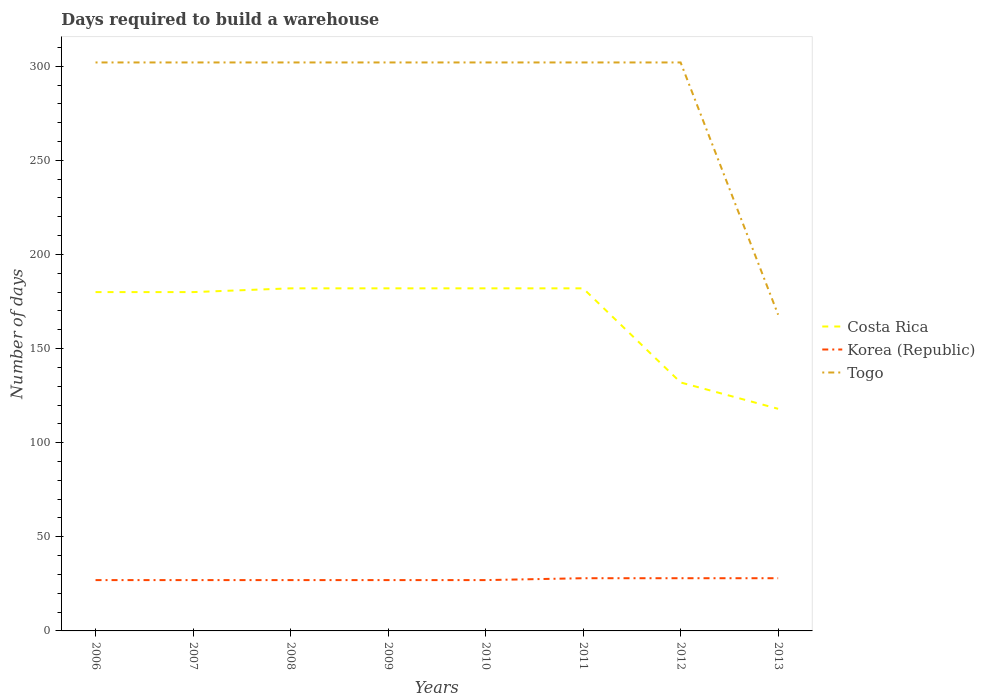How many different coloured lines are there?
Your answer should be very brief. 3. Is the number of lines equal to the number of legend labels?
Make the answer very short. Yes. Across all years, what is the maximum days required to build a warehouse in in Costa Rica?
Your answer should be compact. 118. What is the difference between the highest and the second highest days required to build a warehouse in in Korea (Republic)?
Your answer should be compact. 1. What is the difference between the highest and the lowest days required to build a warehouse in in Korea (Republic)?
Give a very brief answer. 3. How many lines are there?
Your response must be concise. 3. What is the difference between two consecutive major ticks on the Y-axis?
Ensure brevity in your answer.  50. Where does the legend appear in the graph?
Offer a terse response. Center right. How many legend labels are there?
Offer a very short reply. 3. How are the legend labels stacked?
Keep it short and to the point. Vertical. What is the title of the graph?
Provide a short and direct response. Days required to build a warehouse. What is the label or title of the X-axis?
Your response must be concise. Years. What is the label or title of the Y-axis?
Make the answer very short. Number of days. What is the Number of days in Costa Rica in 2006?
Provide a succinct answer. 180. What is the Number of days in Togo in 2006?
Provide a succinct answer. 302. What is the Number of days in Costa Rica in 2007?
Provide a succinct answer. 180. What is the Number of days of Korea (Republic) in 2007?
Your answer should be very brief. 27. What is the Number of days of Togo in 2007?
Your answer should be very brief. 302. What is the Number of days in Costa Rica in 2008?
Your response must be concise. 182. What is the Number of days of Korea (Republic) in 2008?
Provide a succinct answer. 27. What is the Number of days of Togo in 2008?
Give a very brief answer. 302. What is the Number of days of Costa Rica in 2009?
Give a very brief answer. 182. What is the Number of days in Togo in 2009?
Your answer should be compact. 302. What is the Number of days of Costa Rica in 2010?
Your response must be concise. 182. What is the Number of days in Togo in 2010?
Your response must be concise. 302. What is the Number of days of Costa Rica in 2011?
Provide a succinct answer. 182. What is the Number of days of Korea (Republic) in 2011?
Offer a terse response. 28. What is the Number of days in Togo in 2011?
Your answer should be very brief. 302. What is the Number of days in Costa Rica in 2012?
Your answer should be compact. 132. What is the Number of days in Togo in 2012?
Provide a short and direct response. 302. What is the Number of days in Costa Rica in 2013?
Your response must be concise. 118. What is the Number of days in Togo in 2013?
Make the answer very short. 168. Across all years, what is the maximum Number of days of Costa Rica?
Ensure brevity in your answer.  182. Across all years, what is the maximum Number of days of Togo?
Offer a very short reply. 302. Across all years, what is the minimum Number of days of Costa Rica?
Give a very brief answer. 118. Across all years, what is the minimum Number of days in Korea (Republic)?
Give a very brief answer. 27. Across all years, what is the minimum Number of days of Togo?
Your answer should be compact. 168. What is the total Number of days in Costa Rica in the graph?
Provide a succinct answer. 1338. What is the total Number of days in Korea (Republic) in the graph?
Your answer should be compact. 219. What is the total Number of days of Togo in the graph?
Provide a short and direct response. 2282. What is the difference between the Number of days in Togo in 2006 and that in 2007?
Your response must be concise. 0. What is the difference between the Number of days in Costa Rica in 2006 and that in 2009?
Offer a terse response. -2. What is the difference between the Number of days of Korea (Republic) in 2006 and that in 2009?
Keep it short and to the point. 0. What is the difference between the Number of days in Costa Rica in 2006 and that in 2010?
Offer a very short reply. -2. What is the difference between the Number of days of Costa Rica in 2006 and that in 2012?
Offer a terse response. 48. What is the difference between the Number of days of Korea (Republic) in 2006 and that in 2012?
Offer a terse response. -1. What is the difference between the Number of days in Togo in 2006 and that in 2012?
Make the answer very short. 0. What is the difference between the Number of days of Togo in 2006 and that in 2013?
Offer a terse response. 134. What is the difference between the Number of days in Korea (Republic) in 2007 and that in 2008?
Offer a terse response. 0. What is the difference between the Number of days in Costa Rica in 2007 and that in 2009?
Make the answer very short. -2. What is the difference between the Number of days in Togo in 2007 and that in 2009?
Offer a terse response. 0. What is the difference between the Number of days of Costa Rica in 2007 and that in 2010?
Your answer should be compact. -2. What is the difference between the Number of days of Togo in 2007 and that in 2010?
Offer a very short reply. 0. What is the difference between the Number of days in Togo in 2007 and that in 2012?
Make the answer very short. 0. What is the difference between the Number of days of Costa Rica in 2007 and that in 2013?
Your response must be concise. 62. What is the difference between the Number of days in Korea (Republic) in 2007 and that in 2013?
Your answer should be compact. -1. What is the difference between the Number of days in Togo in 2007 and that in 2013?
Your answer should be very brief. 134. What is the difference between the Number of days of Korea (Republic) in 2008 and that in 2010?
Your response must be concise. 0. What is the difference between the Number of days of Togo in 2008 and that in 2010?
Provide a short and direct response. 0. What is the difference between the Number of days in Costa Rica in 2008 and that in 2011?
Ensure brevity in your answer.  0. What is the difference between the Number of days in Korea (Republic) in 2008 and that in 2011?
Your answer should be very brief. -1. What is the difference between the Number of days of Costa Rica in 2008 and that in 2012?
Offer a terse response. 50. What is the difference between the Number of days of Korea (Republic) in 2008 and that in 2012?
Provide a short and direct response. -1. What is the difference between the Number of days of Togo in 2008 and that in 2012?
Offer a terse response. 0. What is the difference between the Number of days in Costa Rica in 2008 and that in 2013?
Ensure brevity in your answer.  64. What is the difference between the Number of days in Korea (Republic) in 2008 and that in 2013?
Offer a terse response. -1. What is the difference between the Number of days of Togo in 2008 and that in 2013?
Provide a succinct answer. 134. What is the difference between the Number of days in Costa Rica in 2009 and that in 2011?
Offer a very short reply. 0. What is the difference between the Number of days in Costa Rica in 2009 and that in 2012?
Your answer should be very brief. 50. What is the difference between the Number of days in Togo in 2009 and that in 2012?
Keep it short and to the point. 0. What is the difference between the Number of days of Costa Rica in 2009 and that in 2013?
Offer a very short reply. 64. What is the difference between the Number of days of Togo in 2009 and that in 2013?
Your answer should be compact. 134. What is the difference between the Number of days of Korea (Republic) in 2010 and that in 2011?
Offer a very short reply. -1. What is the difference between the Number of days of Korea (Republic) in 2010 and that in 2012?
Give a very brief answer. -1. What is the difference between the Number of days of Togo in 2010 and that in 2012?
Your response must be concise. 0. What is the difference between the Number of days in Togo in 2010 and that in 2013?
Keep it short and to the point. 134. What is the difference between the Number of days of Costa Rica in 2011 and that in 2012?
Provide a short and direct response. 50. What is the difference between the Number of days of Costa Rica in 2011 and that in 2013?
Make the answer very short. 64. What is the difference between the Number of days of Togo in 2011 and that in 2013?
Offer a very short reply. 134. What is the difference between the Number of days in Costa Rica in 2012 and that in 2013?
Your answer should be compact. 14. What is the difference between the Number of days in Korea (Republic) in 2012 and that in 2013?
Make the answer very short. 0. What is the difference between the Number of days in Togo in 2012 and that in 2013?
Give a very brief answer. 134. What is the difference between the Number of days of Costa Rica in 2006 and the Number of days of Korea (Republic) in 2007?
Offer a very short reply. 153. What is the difference between the Number of days in Costa Rica in 2006 and the Number of days in Togo in 2007?
Your answer should be very brief. -122. What is the difference between the Number of days of Korea (Republic) in 2006 and the Number of days of Togo in 2007?
Make the answer very short. -275. What is the difference between the Number of days in Costa Rica in 2006 and the Number of days in Korea (Republic) in 2008?
Ensure brevity in your answer.  153. What is the difference between the Number of days in Costa Rica in 2006 and the Number of days in Togo in 2008?
Your answer should be very brief. -122. What is the difference between the Number of days of Korea (Republic) in 2006 and the Number of days of Togo in 2008?
Your answer should be very brief. -275. What is the difference between the Number of days in Costa Rica in 2006 and the Number of days in Korea (Republic) in 2009?
Provide a succinct answer. 153. What is the difference between the Number of days of Costa Rica in 2006 and the Number of days of Togo in 2009?
Provide a short and direct response. -122. What is the difference between the Number of days of Korea (Republic) in 2006 and the Number of days of Togo in 2009?
Offer a very short reply. -275. What is the difference between the Number of days of Costa Rica in 2006 and the Number of days of Korea (Republic) in 2010?
Give a very brief answer. 153. What is the difference between the Number of days of Costa Rica in 2006 and the Number of days of Togo in 2010?
Make the answer very short. -122. What is the difference between the Number of days in Korea (Republic) in 2006 and the Number of days in Togo in 2010?
Give a very brief answer. -275. What is the difference between the Number of days of Costa Rica in 2006 and the Number of days of Korea (Republic) in 2011?
Your answer should be compact. 152. What is the difference between the Number of days of Costa Rica in 2006 and the Number of days of Togo in 2011?
Keep it short and to the point. -122. What is the difference between the Number of days in Korea (Republic) in 2006 and the Number of days in Togo in 2011?
Your answer should be very brief. -275. What is the difference between the Number of days of Costa Rica in 2006 and the Number of days of Korea (Republic) in 2012?
Provide a short and direct response. 152. What is the difference between the Number of days in Costa Rica in 2006 and the Number of days in Togo in 2012?
Give a very brief answer. -122. What is the difference between the Number of days of Korea (Republic) in 2006 and the Number of days of Togo in 2012?
Offer a terse response. -275. What is the difference between the Number of days in Costa Rica in 2006 and the Number of days in Korea (Republic) in 2013?
Keep it short and to the point. 152. What is the difference between the Number of days in Costa Rica in 2006 and the Number of days in Togo in 2013?
Ensure brevity in your answer.  12. What is the difference between the Number of days in Korea (Republic) in 2006 and the Number of days in Togo in 2013?
Offer a very short reply. -141. What is the difference between the Number of days in Costa Rica in 2007 and the Number of days in Korea (Republic) in 2008?
Make the answer very short. 153. What is the difference between the Number of days in Costa Rica in 2007 and the Number of days in Togo in 2008?
Keep it short and to the point. -122. What is the difference between the Number of days of Korea (Republic) in 2007 and the Number of days of Togo in 2008?
Offer a very short reply. -275. What is the difference between the Number of days in Costa Rica in 2007 and the Number of days in Korea (Republic) in 2009?
Offer a terse response. 153. What is the difference between the Number of days in Costa Rica in 2007 and the Number of days in Togo in 2009?
Your answer should be compact. -122. What is the difference between the Number of days of Korea (Republic) in 2007 and the Number of days of Togo in 2009?
Your answer should be very brief. -275. What is the difference between the Number of days of Costa Rica in 2007 and the Number of days of Korea (Republic) in 2010?
Provide a short and direct response. 153. What is the difference between the Number of days of Costa Rica in 2007 and the Number of days of Togo in 2010?
Provide a succinct answer. -122. What is the difference between the Number of days of Korea (Republic) in 2007 and the Number of days of Togo in 2010?
Give a very brief answer. -275. What is the difference between the Number of days of Costa Rica in 2007 and the Number of days of Korea (Republic) in 2011?
Your response must be concise. 152. What is the difference between the Number of days in Costa Rica in 2007 and the Number of days in Togo in 2011?
Offer a very short reply. -122. What is the difference between the Number of days of Korea (Republic) in 2007 and the Number of days of Togo in 2011?
Provide a succinct answer. -275. What is the difference between the Number of days in Costa Rica in 2007 and the Number of days in Korea (Republic) in 2012?
Provide a short and direct response. 152. What is the difference between the Number of days of Costa Rica in 2007 and the Number of days of Togo in 2012?
Ensure brevity in your answer.  -122. What is the difference between the Number of days in Korea (Republic) in 2007 and the Number of days in Togo in 2012?
Ensure brevity in your answer.  -275. What is the difference between the Number of days of Costa Rica in 2007 and the Number of days of Korea (Republic) in 2013?
Ensure brevity in your answer.  152. What is the difference between the Number of days in Korea (Republic) in 2007 and the Number of days in Togo in 2013?
Your answer should be compact. -141. What is the difference between the Number of days of Costa Rica in 2008 and the Number of days of Korea (Republic) in 2009?
Your answer should be very brief. 155. What is the difference between the Number of days of Costa Rica in 2008 and the Number of days of Togo in 2009?
Your answer should be very brief. -120. What is the difference between the Number of days of Korea (Republic) in 2008 and the Number of days of Togo in 2009?
Offer a terse response. -275. What is the difference between the Number of days of Costa Rica in 2008 and the Number of days of Korea (Republic) in 2010?
Make the answer very short. 155. What is the difference between the Number of days of Costa Rica in 2008 and the Number of days of Togo in 2010?
Ensure brevity in your answer.  -120. What is the difference between the Number of days in Korea (Republic) in 2008 and the Number of days in Togo in 2010?
Provide a short and direct response. -275. What is the difference between the Number of days in Costa Rica in 2008 and the Number of days in Korea (Republic) in 2011?
Give a very brief answer. 154. What is the difference between the Number of days in Costa Rica in 2008 and the Number of days in Togo in 2011?
Give a very brief answer. -120. What is the difference between the Number of days of Korea (Republic) in 2008 and the Number of days of Togo in 2011?
Make the answer very short. -275. What is the difference between the Number of days of Costa Rica in 2008 and the Number of days of Korea (Republic) in 2012?
Your response must be concise. 154. What is the difference between the Number of days in Costa Rica in 2008 and the Number of days in Togo in 2012?
Provide a short and direct response. -120. What is the difference between the Number of days in Korea (Republic) in 2008 and the Number of days in Togo in 2012?
Your answer should be very brief. -275. What is the difference between the Number of days in Costa Rica in 2008 and the Number of days in Korea (Republic) in 2013?
Keep it short and to the point. 154. What is the difference between the Number of days of Korea (Republic) in 2008 and the Number of days of Togo in 2013?
Provide a short and direct response. -141. What is the difference between the Number of days in Costa Rica in 2009 and the Number of days in Korea (Republic) in 2010?
Your answer should be very brief. 155. What is the difference between the Number of days in Costa Rica in 2009 and the Number of days in Togo in 2010?
Provide a succinct answer. -120. What is the difference between the Number of days in Korea (Republic) in 2009 and the Number of days in Togo in 2010?
Keep it short and to the point. -275. What is the difference between the Number of days of Costa Rica in 2009 and the Number of days of Korea (Republic) in 2011?
Provide a succinct answer. 154. What is the difference between the Number of days in Costa Rica in 2009 and the Number of days in Togo in 2011?
Your response must be concise. -120. What is the difference between the Number of days of Korea (Republic) in 2009 and the Number of days of Togo in 2011?
Ensure brevity in your answer.  -275. What is the difference between the Number of days in Costa Rica in 2009 and the Number of days in Korea (Republic) in 2012?
Your response must be concise. 154. What is the difference between the Number of days in Costa Rica in 2009 and the Number of days in Togo in 2012?
Provide a short and direct response. -120. What is the difference between the Number of days in Korea (Republic) in 2009 and the Number of days in Togo in 2012?
Keep it short and to the point. -275. What is the difference between the Number of days in Costa Rica in 2009 and the Number of days in Korea (Republic) in 2013?
Give a very brief answer. 154. What is the difference between the Number of days of Korea (Republic) in 2009 and the Number of days of Togo in 2013?
Ensure brevity in your answer.  -141. What is the difference between the Number of days of Costa Rica in 2010 and the Number of days of Korea (Republic) in 2011?
Provide a short and direct response. 154. What is the difference between the Number of days of Costa Rica in 2010 and the Number of days of Togo in 2011?
Offer a very short reply. -120. What is the difference between the Number of days of Korea (Republic) in 2010 and the Number of days of Togo in 2011?
Give a very brief answer. -275. What is the difference between the Number of days of Costa Rica in 2010 and the Number of days of Korea (Republic) in 2012?
Keep it short and to the point. 154. What is the difference between the Number of days in Costa Rica in 2010 and the Number of days in Togo in 2012?
Offer a very short reply. -120. What is the difference between the Number of days of Korea (Republic) in 2010 and the Number of days of Togo in 2012?
Keep it short and to the point. -275. What is the difference between the Number of days in Costa Rica in 2010 and the Number of days in Korea (Republic) in 2013?
Offer a very short reply. 154. What is the difference between the Number of days in Korea (Republic) in 2010 and the Number of days in Togo in 2013?
Offer a very short reply. -141. What is the difference between the Number of days in Costa Rica in 2011 and the Number of days in Korea (Republic) in 2012?
Provide a short and direct response. 154. What is the difference between the Number of days of Costa Rica in 2011 and the Number of days of Togo in 2012?
Offer a terse response. -120. What is the difference between the Number of days in Korea (Republic) in 2011 and the Number of days in Togo in 2012?
Provide a short and direct response. -274. What is the difference between the Number of days in Costa Rica in 2011 and the Number of days in Korea (Republic) in 2013?
Give a very brief answer. 154. What is the difference between the Number of days of Costa Rica in 2011 and the Number of days of Togo in 2013?
Your answer should be very brief. 14. What is the difference between the Number of days of Korea (Republic) in 2011 and the Number of days of Togo in 2013?
Provide a succinct answer. -140. What is the difference between the Number of days in Costa Rica in 2012 and the Number of days in Korea (Republic) in 2013?
Offer a very short reply. 104. What is the difference between the Number of days in Costa Rica in 2012 and the Number of days in Togo in 2013?
Ensure brevity in your answer.  -36. What is the difference between the Number of days of Korea (Republic) in 2012 and the Number of days of Togo in 2013?
Give a very brief answer. -140. What is the average Number of days of Costa Rica per year?
Provide a short and direct response. 167.25. What is the average Number of days in Korea (Republic) per year?
Offer a very short reply. 27.38. What is the average Number of days in Togo per year?
Your response must be concise. 285.25. In the year 2006, what is the difference between the Number of days in Costa Rica and Number of days in Korea (Republic)?
Your response must be concise. 153. In the year 2006, what is the difference between the Number of days in Costa Rica and Number of days in Togo?
Provide a short and direct response. -122. In the year 2006, what is the difference between the Number of days in Korea (Republic) and Number of days in Togo?
Provide a succinct answer. -275. In the year 2007, what is the difference between the Number of days in Costa Rica and Number of days in Korea (Republic)?
Make the answer very short. 153. In the year 2007, what is the difference between the Number of days of Costa Rica and Number of days of Togo?
Give a very brief answer. -122. In the year 2007, what is the difference between the Number of days in Korea (Republic) and Number of days in Togo?
Provide a succinct answer. -275. In the year 2008, what is the difference between the Number of days in Costa Rica and Number of days in Korea (Republic)?
Make the answer very short. 155. In the year 2008, what is the difference between the Number of days of Costa Rica and Number of days of Togo?
Your response must be concise. -120. In the year 2008, what is the difference between the Number of days of Korea (Republic) and Number of days of Togo?
Your answer should be compact. -275. In the year 2009, what is the difference between the Number of days in Costa Rica and Number of days in Korea (Republic)?
Keep it short and to the point. 155. In the year 2009, what is the difference between the Number of days of Costa Rica and Number of days of Togo?
Make the answer very short. -120. In the year 2009, what is the difference between the Number of days of Korea (Republic) and Number of days of Togo?
Make the answer very short. -275. In the year 2010, what is the difference between the Number of days of Costa Rica and Number of days of Korea (Republic)?
Keep it short and to the point. 155. In the year 2010, what is the difference between the Number of days in Costa Rica and Number of days in Togo?
Offer a very short reply. -120. In the year 2010, what is the difference between the Number of days in Korea (Republic) and Number of days in Togo?
Ensure brevity in your answer.  -275. In the year 2011, what is the difference between the Number of days in Costa Rica and Number of days in Korea (Republic)?
Provide a short and direct response. 154. In the year 2011, what is the difference between the Number of days in Costa Rica and Number of days in Togo?
Keep it short and to the point. -120. In the year 2011, what is the difference between the Number of days of Korea (Republic) and Number of days of Togo?
Keep it short and to the point. -274. In the year 2012, what is the difference between the Number of days of Costa Rica and Number of days of Korea (Republic)?
Your answer should be compact. 104. In the year 2012, what is the difference between the Number of days in Costa Rica and Number of days in Togo?
Your answer should be very brief. -170. In the year 2012, what is the difference between the Number of days in Korea (Republic) and Number of days in Togo?
Provide a succinct answer. -274. In the year 2013, what is the difference between the Number of days of Costa Rica and Number of days of Korea (Republic)?
Your answer should be very brief. 90. In the year 2013, what is the difference between the Number of days in Korea (Republic) and Number of days in Togo?
Keep it short and to the point. -140. What is the ratio of the Number of days in Korea (Republic) in 2006 to that in 2007?
Offer a terse response. 1. What is the ratio of the Number of days in Costa Rica in 2006 to that in 2008?
Make the answer very short. 0.99. What is the ratio of the Number of days in Korea (Republic) in 2006 to that in 2008?
Offer a terse response. 1. What is the ratio of the Number of days in Togo in 2006 to that in 2008?
Your answer should be very brief. 1. What is the ratio of the Number of days in Togo in 2006 to that in 2009?
Offer a terse response. 1. What is the ratio of the Number of days of Korea (Republic) in 2006 to that in 2010?
Your answer should be compact. 1. What is the ratio of the Number of days of Togo in 2006 to that in 2010?
Offer a terse response. 1. What is the ratio of the Number of days in Costa Rica in 2006 to that in 2011?
Keep it short and to the point. 0.99. What is the ratio of the Number of days of Togo in 2006 to that in 2011?
Offer a terse response. 1. What is the ratio of the Number of days in Costa Rica in 2006 to that in 2012?
Give a very brief answer. 1.36. What is the ratio of the Number of days in Korea (Republic) in 2006 to that in 2012?
Offer a very short reply. 0.96. What is the ratio of the Number of days in Costa Rica in 2006 to that in 2013?
Make the answer very short. 1.53. What is the ratio of the Number of days of Togo in 2006 to that in 2013?
Keep it short and to the point. 1.8. What is the ratio of the Number of days in Costa Rica in 2007 to that in 2008?
Ensure brevity in your answer.  0.99. What is the ratio of the Number of days in Costa Rica in 2007 to that in 2009?
Make the answer very short. 0.99. What is the ratio of the Number of days of Togo in 2007 to that in 2009?
Offer a very short reply. 1. What is the ratio of the Number of days of Korea (Republic) in 2007 to that in 2010?
Ensure brevity in your answer.  1. What is the ratio of the Number of days in Costa Rica in 2007 to that in 2011?
Provide a succinct answer. 0.99. What is the ratio of the Number of days in Togo in 2007 to that in 2011?
Your answer should be compact. 1. What is the ratio of the Number of days of Costa Rica in 2007 to that in 2012?
Your response must be concise. 1.36. What is the ratio of the Number of days in Costa Rica in 2007 to that in 2013?
Your answer should be compact. 1.53. What is the ratio of the Number of days in Togo in 2007 to that in 2013?
Keep it short and to the point. 1.8. What is the ratio of the Number of days of Costa Rica in 2008 to that in 2009?
Your response must be concise. 1. What is the ratio of the Number of days of Korea (Republic) in 2008 to that in 2009?
Give a very brief answer. 1. What is the ratio of the Number of days of Costa Rica in 2008 to that in 2010?
Provide a short and direct response. 1. What is the ratio of the Number of days in Korea (Republic) in 2008 to that in 2010?
Offer a very short reply. 1. What is the ratio of the Number of days in Togo in 2008 to that in 2010?
Your response must be concise. 1. What is the ratio of the Number of days of Togo in 2008 to that in 2011?
Provide a short and direct response. 1. What is the ratio of the Number of days of Costa Rica in 2008 to that in 2012?
Offer a very short reply. 1.38. What is the ratio of the Number of days in Korea (Republic) in 2008 to that in 2012?
Your response must be concise. 0.96. What is the ratio of the Number of days of Costa Rica in 2008 to that in 2013?
Your answer should be compact. 1.54. What is the ratio of the Number of days of Korea (Republic) in 2008 to that in 2013?
Provide a short and direct response. 0.96. What is the ratio of the Number of days in Togo in 2008 to that in 2013?
Your response must be concise. 1.8. What is the ratio of the Number of days of Costa Rica in 2009 to that in 2011?
Your answer should be compact. 1. What is the ratio of the Number of days of Costa Rica in 2009 to that in 2012?
Your answer should be compact. 1.38. What is the ratio of the Number of days of Costa Rica in 2009 to that in 2013?
Keep it short and to the point. 1.54. What is the ratio of the Number of days of Togo in 2009 to that in 2013?
Make the answer very short. 1.8. What is the ratio of the Number of days of Togo in 2010 to that in 2011?
Offer a terse response. 1. What is the ratio of the Number of days in Costa Rica in 2010 to that in 2012?
Offer a very short reply. 1.38. What is the ratio of the Number of days in Korea (Republic) in 2010 to that in 2012?
Provide a succinct answer. 0.96. What is the ratio of the Number of days in Togo in 2010 to that in 2012?
Ensure brevity in your answer.  1. What is the ratio of the Number of days in Costa Rica in 2010 to that in 2013?
Your response must be concise. 1.54. What is the ratio of the Number of days of Korea (Republic) in 2010 to that in 2013?
Your response must be concise. 0.96. What is the ratio of the Number of days of Togo in 2010 to that in 2013?
Your answer should be very brief. 1.8. What is the ratio of the Number of days of Costa Rica in 2011 to that in 2012?
Your response must be concise. 1.38. What is the ratio of the Number of days of Korea (Republic) in 2011 to that in 2012?
Keep it short and to the point. 1. What is the ratio of the Number of days of Costa Rica in 2011 to that in 2013?
Your response must be concise. 1.54. What is the ratio of the Number of days of Togo in 2011 to that in 2013?
Your response must be concise. 1.8. What is the ratio of the Number of days of Costa Rica in 2012 to that in 2013?
Your response must be concise. 1.12. What is the ratio of the Number of days in Togo in 2012 to that in 2013?
Your answer should be very brief. 1.8. What is the difference between the highest and the lowest Number of days in Togo?
Your response must be concise. 134. 